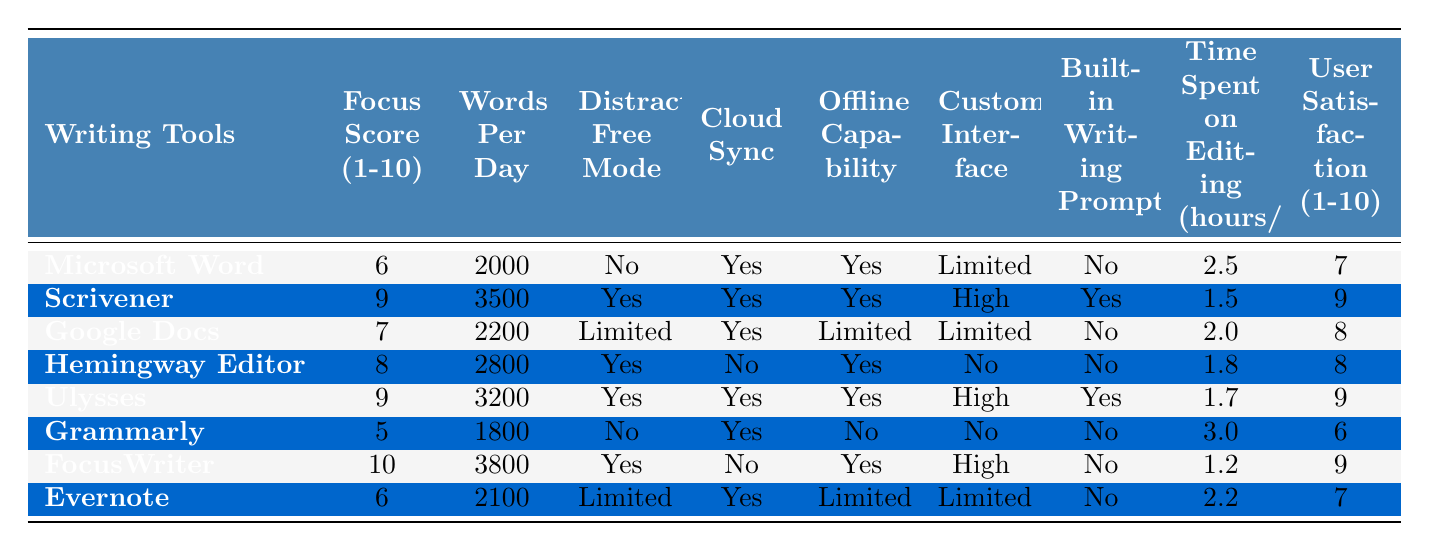What is the focus score of Scrivener? The focus score of Scrivener is listed in the table under the "Focus Score (1-10)" column, which shows a value of 9.
Answer: 9 How many words per day can a user expect to write using FocusWriter? The number of words per day for FocusWriter is found in the "Words Per Day" column, where it shows a value of 3800.
Answer: 3800 Which writing tool has the highest user satisfaction score? Focusing on the "User Satisfaction (1-10)" column, we can identify that both Scrivener and Ulysses have the highest score of 9.
Answer: Scrivener and Ulysses Does Grammarly have a distraction-free mode? In the "Distraction-Free Mode" column, Grammarly is marked with a "No," indicating that it does not have this feature.
Answer: No What is the average focus score of all the writing tools? To find the average focus score, we add all the focus scores (6 + 9 + 7 + 8 + 9 + 5 + 10 + 6 = 60) and divide by the number of tools (8), which gives us 60/8 = 7.5.
Answer: 7.5 How many writing tools have a customizable interface categorized as 'High'? Looking at the "Customizable Interface" column, we can see that Scrivener, Ulysses, and FocusWriter are categorized as 'High,' making it three tools in total.
Answer: 3 What is the difference in words per day between the tools with the highest and lowest focus scores? FocusWriter has the highest focus score of 10 with 3800 words per day, while Grammarly has the lowest focus score of 5 with 1800 words. The difference in words per day is 3800 - 1800 = 2000.
Answer: 2000 Which writing tool has the highest focus score but does not have cloud sync capability? Among the writing tools, Grammarly has a focus score of 5 and lacks cloud sync capabilities. However, FocusWriter has the highest score of 10 and also lacks cloud sync, making it the answer.
Answer: FocusWriter What percentage of the tools listed have built-in writing prompts? Checking the "Built-in Writing Prompts" column, only Scrivener and Ulysses have built-in writing prompts while there are 8 tools in total. This gives us (2/8) * 100 = 25%.
Answer: 25% Which tool requires the most time spent on editing daily? By examining the "Time Spent on Editing (hours/day)" column, Grammarly has the highest editing time of 3.0 hours per day.
Answer: Grammarly 